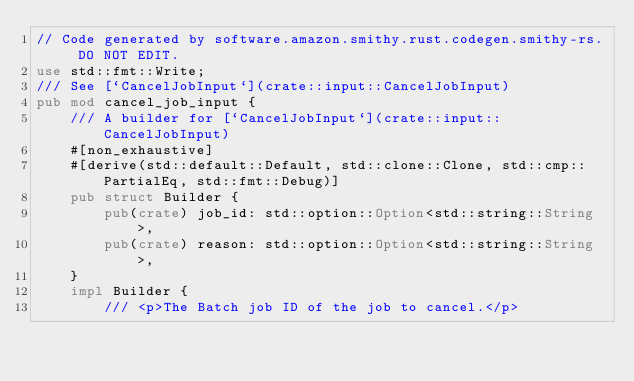Convert code to text. <code><loc_0><loc_0><loc_500><loc_500><_Rust_>// Code generated by software.amazon.smithy.rust.codegen.smithy-rs. DO NOT EDIT.
use std::fmt::Write;
/// See [`CancelJobInput`](crate::input::CancelJobInput)
pub mod cancel_job_input {
    /// A builder for [`CancelJobInput`](crate::input::CancelJobInput)
    #[non_exhaustive]
    #[derive(std::default::Default, std::clone::Clone, std::cmp::PartialEq, std::fmt::Debug)]
    pub struct Builder {
        pub(crate) job_id: std::option::Option<std::string::String>,
        pub(crate) reason: std::option::Option<std::string::String>,
    }
    impl Builder {
        /// <p>The Batch job ID of the job to cancel.</p></code> 